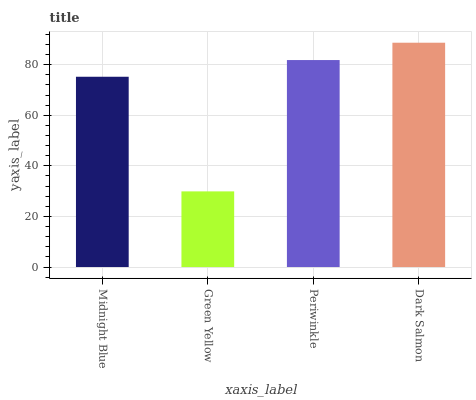Is Green Yellow the minimum?
Answer yes or no. Yes. Is Dark Salmon the maximum?
Answer yes or no. Yes. Is Periwinkle the minimum?
Answer yes or no. No. Is Periwinkle the maximum?
Answer yes or no. No. Is Periwinkle greater than Green Yellow?
Answer yes or no. Yes. Is Green Yellow less than Periwinkle?
Answer yes or no. Yes. Is Green Yellow greater than Periwinkle?
Answer yes or no. No. Is Periwinkle less than Green Yellow?
Answer yes or no. No. Is Periwinkle the high median?
Answer yes or no. Yes. Is Midnight Blue the low median?
Answer yes or no. Yes. Is Midnight Blue the high median?
Answer yes or no. No. Is Periwinkle the low median?
Answer yes or no. No. 